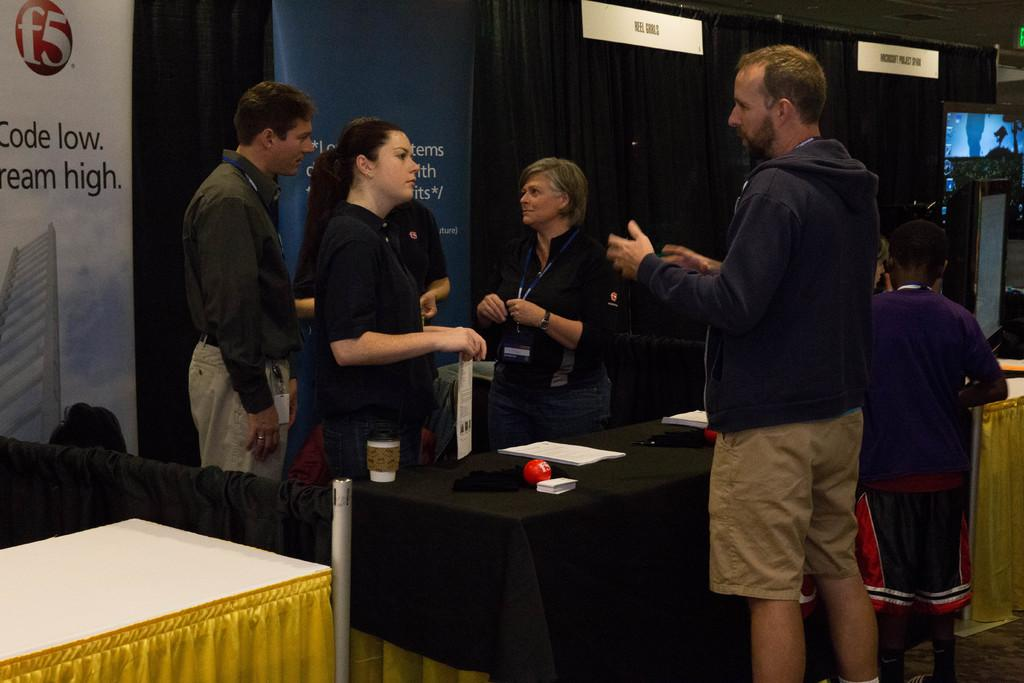How many people are in the image? There are persons standing in the image. What is the color of the curtain in the image? There is a black curtain in the image. What is placed in front of the black curtain? There are banners in front of the black curtain. What furniture is present in the image? There is a table in the image. What is on top of the table? A cloth, a cup, papers, and a ball are on the table. What is the podium used for in the image? The podium is present in the image. Can you tell me how many kisses are exchanged between the persons in the image? There is no information about kisses in the image; it only shows persons standing, a black curtain, banners, a table, a cloth, a cup, papers, a ball, and a podium. What type of order is being given by the person at the podium? There is no person at the podium in the image, and therefore no order is being given. 